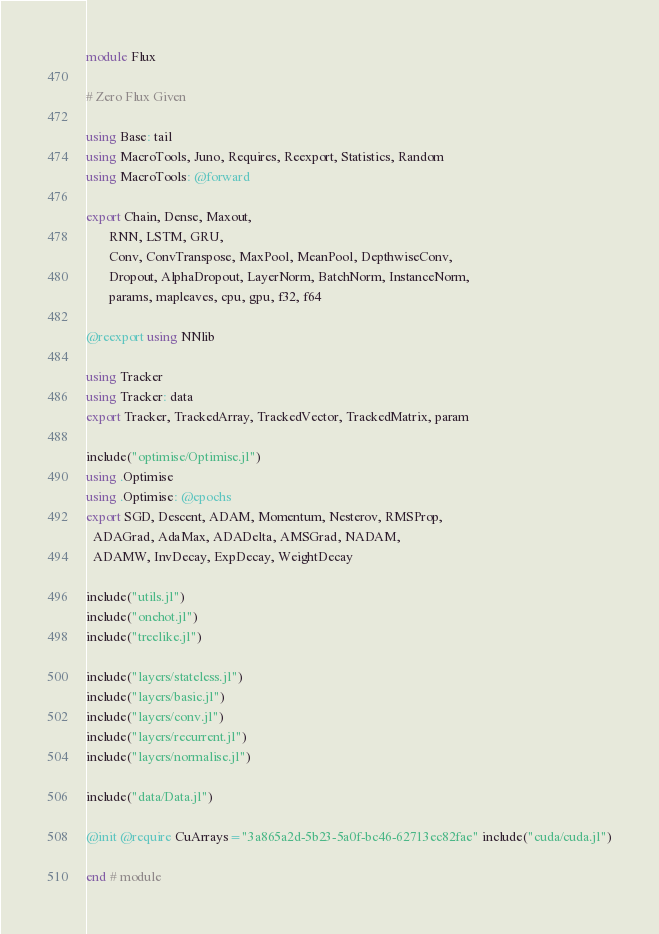<code> <loc_0><loc_0><loc_500><loc_500><_Julia_>module Flux

# Zero Flux Given

using Base: tail
using MacroTools, Juno, Requires, Reexport, Statistics, Random
using MacroTools: @forward

export Chain, Dense, Maxout,
       RNN, LSTM, GRU,
       Conv, ConvTranspose, MaxPool, MeanPool, DepthwiseConv,
       Dropout, AlphaDropout, LayerNorm, BatchNorm, InstanceNorm,
       params, mapleaves, cpu, gpu, f32, f64

@reexport using NNlib

using Tracker
using Tracker: data
export Tracker, TrackedArray, TrackedVector, TrackedMatrix, param

include("optimise/Optimise.jl")
using .Optimise
using .Optimise: @epochs
export SGD, Descent, ADAM, Momentum, Nesterov, RMSProp,
  ADAGrad, AdaMax, ADADelta, AMSGrad, NADAM,
  ADAMW, InvDecay, ExpDecay, WeightDecay

include("utils.jl")
include("onehot.jl")
include("treelike.jl")

include("layers/stateless.jl")
include("layers/basic.jl")
include("layers/conv.jl")
include("layers/recurrent.jl")
include("layers/normalise.jl")

include("data/Data.jl")

@init @require CuArrays="3a865a2d-5b23-5a0f-bc46-62713ec82fae" include("cuda/cuda.jl")

end # module
</code> 